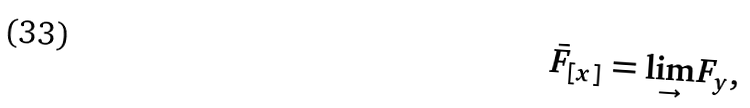Convert formula to latex. <formula><loc_0><loc_0><loc_500><loc_500>\bar { F } _ { [ x ] } = \underset { \rightarrow } { \lim } F _ { y } ,</formula> 